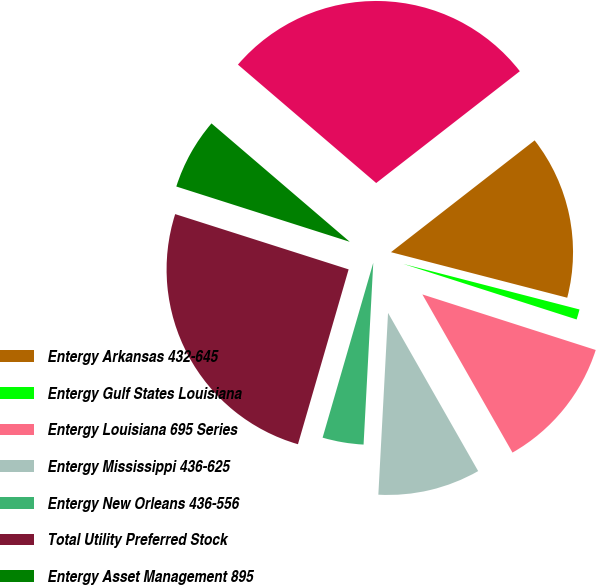<chart> <loc_0><loc_0><loc_500><loc_500><pie_chart><fcel>Entergy Arkansas 432-645<fcel>Entergy Gulf States Louisiana<fcel>Entergy Louisiana 695 Series<fcel>Entergy Mississippi 436-625<fcel>Entergy New Orleans 436-556<fcel>Total Utility Preferred Stock<fcel>Entergy Asset Management 895<fcel>Total Preferred Stock or<nl><fcel>14.55%<fcel>0.91%<fcel>11.82%<fcel>9.09%<fcel>3.64%<fcel>25.42%<fcel>6.36%<fcel>28.2%<nl></chart> 